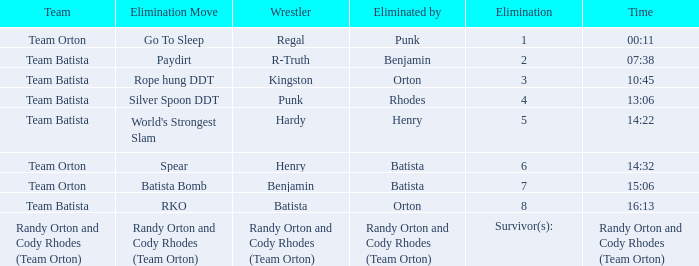Which Elimination move is listed against Team Orton, Eliminated by Batista against Elimination number 7? Batista Bomb. 